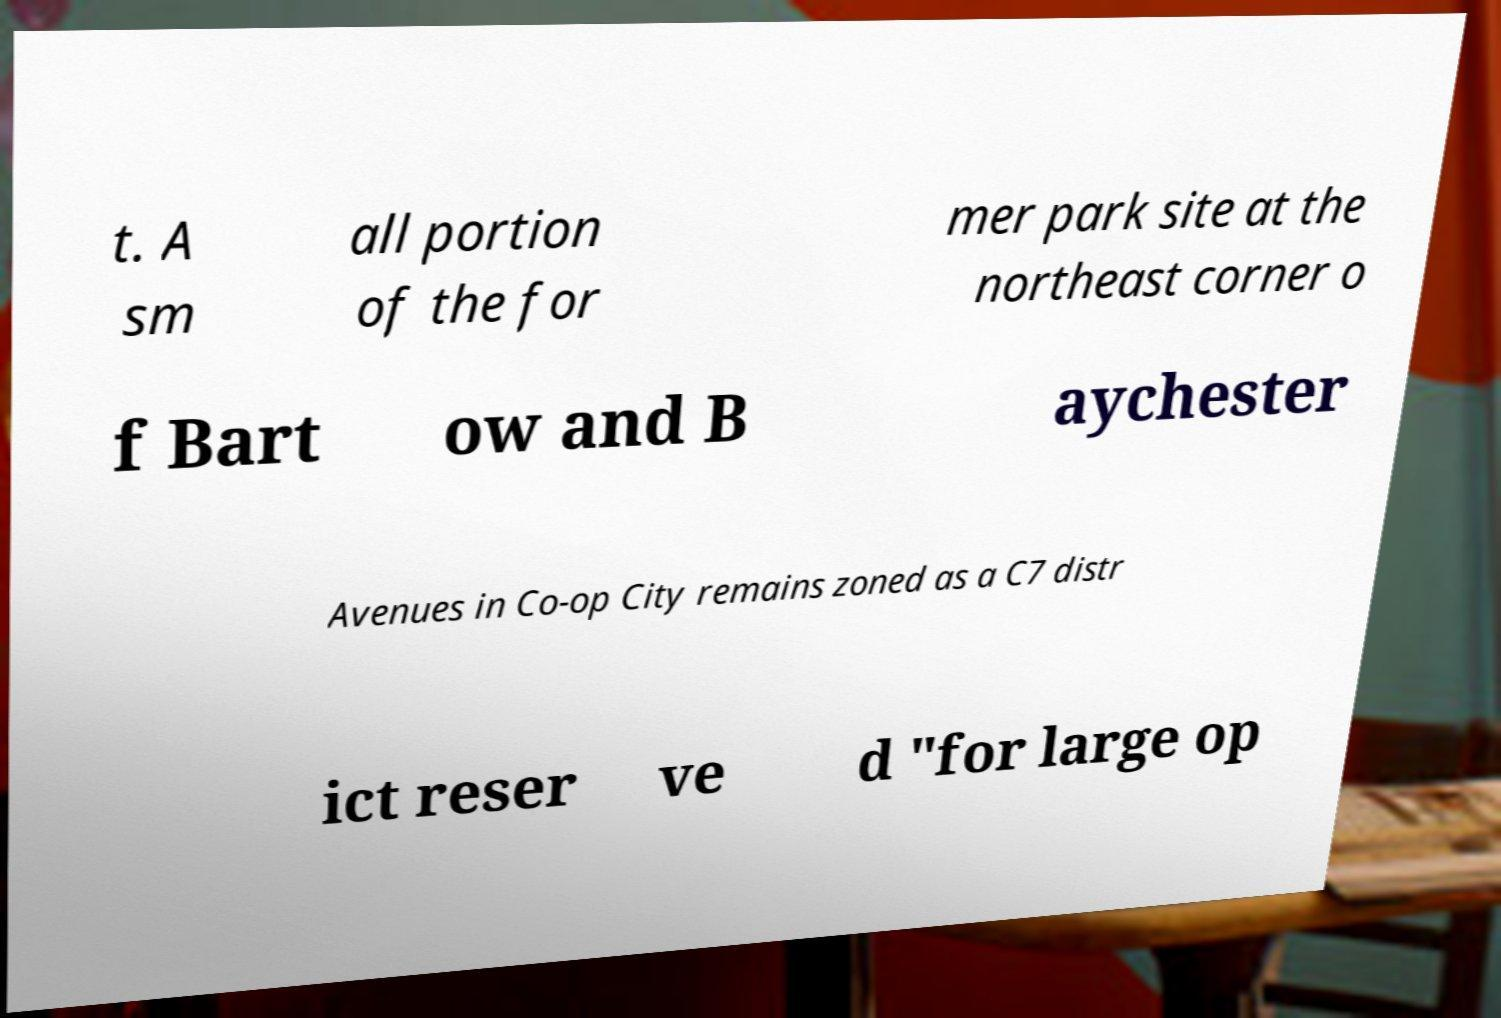There's text embedded in this image that I need extracted. Can you transcribe it verbatim? t. A sm all portion of the for mer park site at the northeast corner o f Bart ow and B aychester Avenues in Co-op City remains zoned as a C7 distr ict reser ve d "for large op 